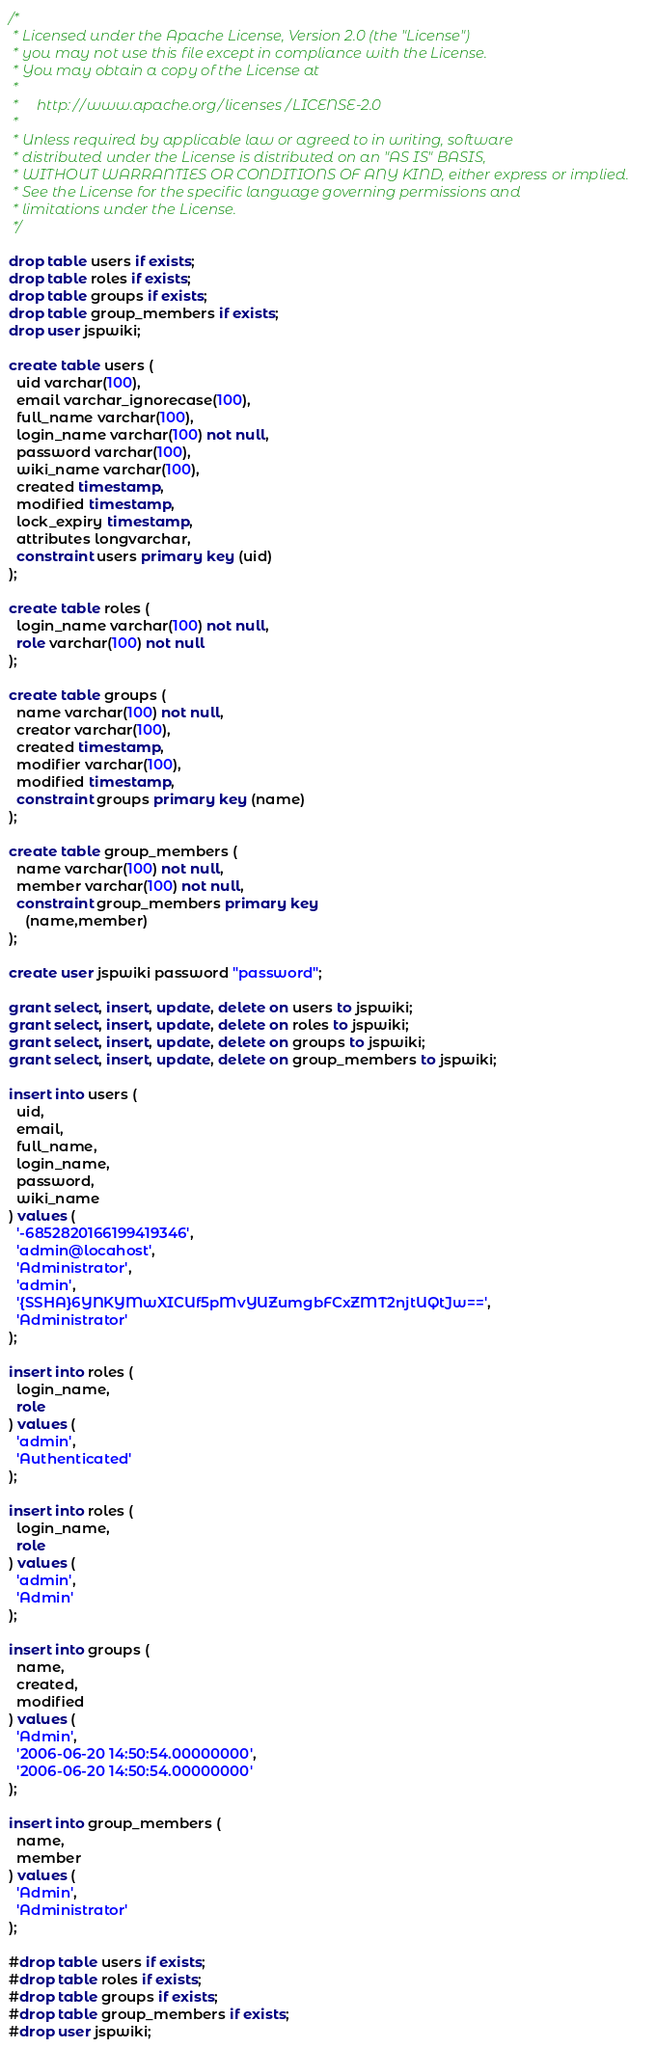Convert code to text. <code><loc_0><loc_0><loc_500><loc_500><_SQL_>/*
 * Licensed under the Apache License, Version 2.0 (the "License")
 * you may not use this file except in compliance with the License.
 * You may obtain a copy of the License at
 *
 *     http://www.apache.org/licenses/LICENSE-2.0
 *
 * Unless required by applicable law or agreed to in writing, software
 * distributed under the License is distributed on an "AS IS" BASIS,
 * WITHOUT WARRANTIES OR CONDITIONS OF ANY KIND, either express or implied.
 * See the License for the specific language governing permissions and
 * limitations under the License.
 */

drop table users if exists;
drop table roles if exists;
drop table groups if exists;
drop table group_members if exists;
drop user jspwiki;

create table users (
  uid varchar(100),
  email varchar_ignorecase(100),
  full_name varchar(100),
  login_name varchar(100) not null,
  password varchar(100),
  wiki_name varchar(100),
  created timestamp,
  modified timestamp,
  lock_expiry timestamp,
  attributes longvarchar,
  constraint users primary key (uid)
);

create table roles (
  login_name varchar(100) not null,
  role varchar(100) not null
);

create table groups (
  name varchar(100) not null,
  creator varchar(100),
  created timestamp,
  modifier varchar(100),
  modified timestamp,
  constraint groups primary key (name)
);

create table group_members (
  name varchar(100) not null,
  member varchar(100) not null,
  constraint group_members primary key
    (name,member)
);

create user jspwiki password "password";

grant select, insert, update, delete on users to jspwiki;
grant select, insert, update, delete on roles to jspwiki;
grant select, insert, update, delete on groups to jspwiki;
grant select, insert, update, delete on group_members to jspwiki;

insert into users (
  uid,
  email,
  full_name,
  login_name,
  password,
  wiki_name
) values (
  '-6852820166199419346',
  'admin@locahost',
  'Administrator',
  'admin',
  '{SSHA}6YNKYMwXICUf5pMvYUZumgbFCxZMT2njtUQtJw==',
  'Administrator'
);

insert into roles (
  login_name,
  role
) values (  
  'admin',
  'Authenticated'
);

insert into roles (
  login_name,
  role
) values (  
  'admin',
  'Admin'
);

insert into groups (
  name,
  created,
  modified
) values (
  'Admin',
  '2006-06-20 14:50:54.00000000',
  '2006-06-20 14:50:54.00000000'
);

insert into group_members (
  name,
  member
) values (  
  'Admin',
  'Administrator'
);

#drop table users if exists;
#drop table roles if exists;
#drop table groups if exists;
#drop table group_members if exists;
#drop user jspwiki;
</code> 